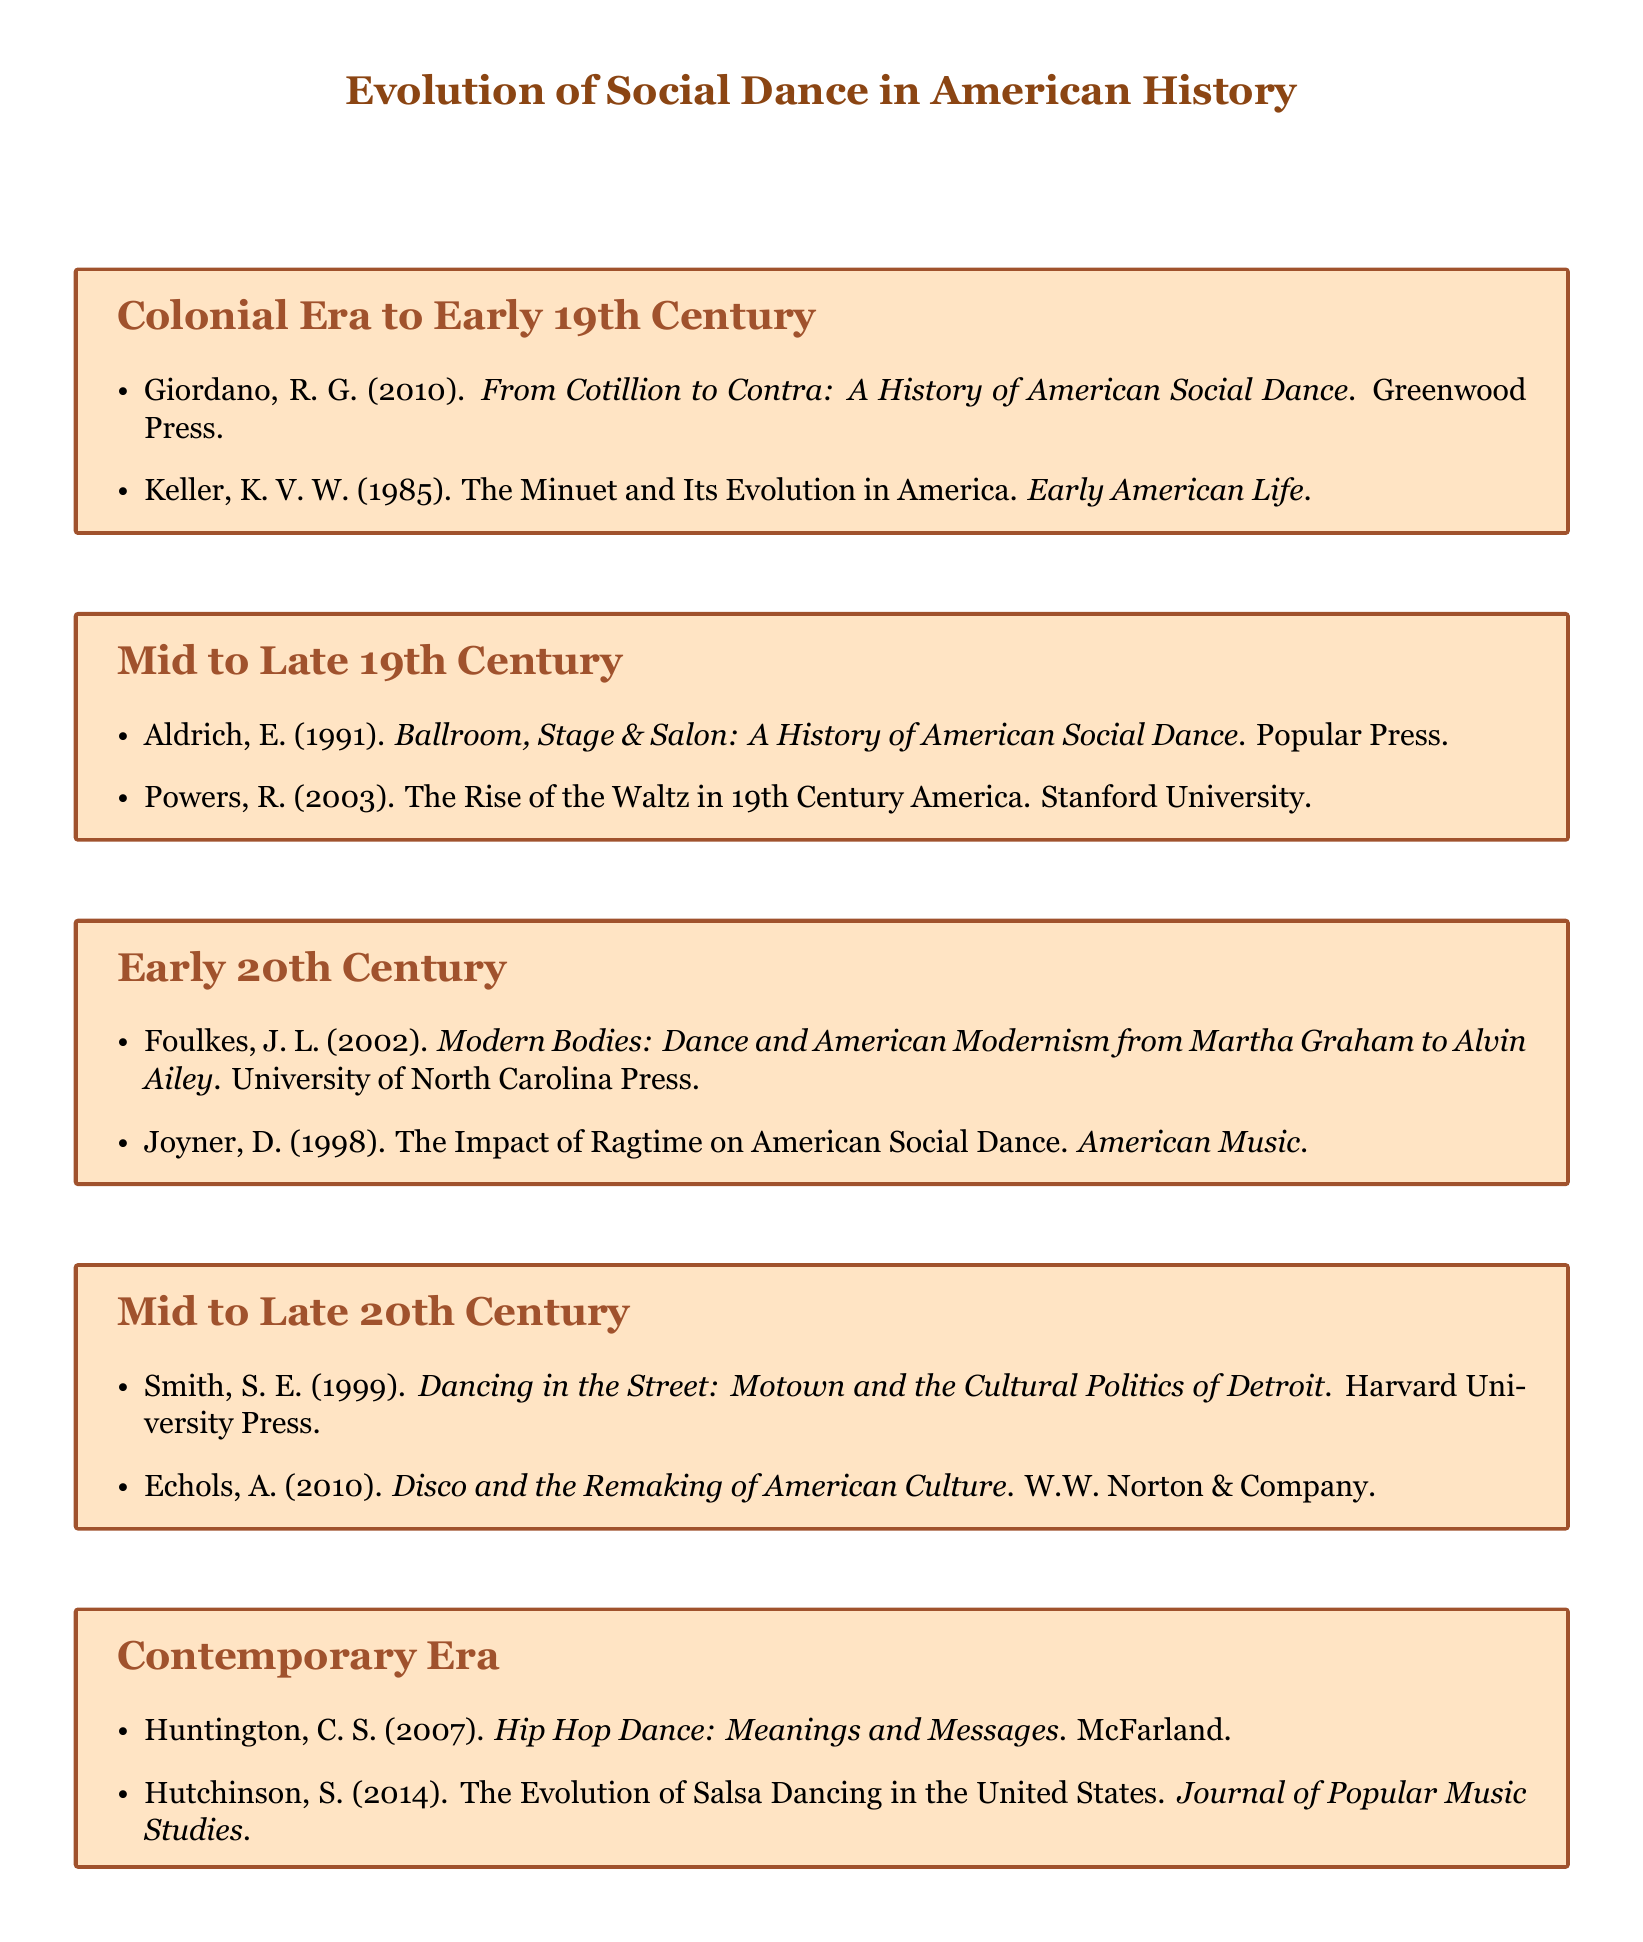What is the title of the first book listed? The first book listed is found in the section "Colonial Era to Early 19th Century" and is authored by R. G. Giordano.
Answer: From Cotillion to Contra: A History of American Social Dance How many items are listed in the "Mid to Late 19th Century" section? There are two items listed under the section "Mid to Late 19th Century."
Answer: 2 Who wrote "Hip Hop Dance: Meanings and Messages"? This title is in the "Contemporary Era" section of the document and was written by C. S. Huntington.
Answer: C. S. Huntington What is the publication year of "Dancing in the Street: Motown and the Cultural Politics of Detroit"? This book is listed in the "Mid to Late 20th Century" section and was published in 1999.
Answer: 1999 Which dance genre is discussed in the article by S. Hutchinson? The article focuses on the evolution of a specific dance genre within the "Contemporary Era" section.
Answer: Salsa Dancing 